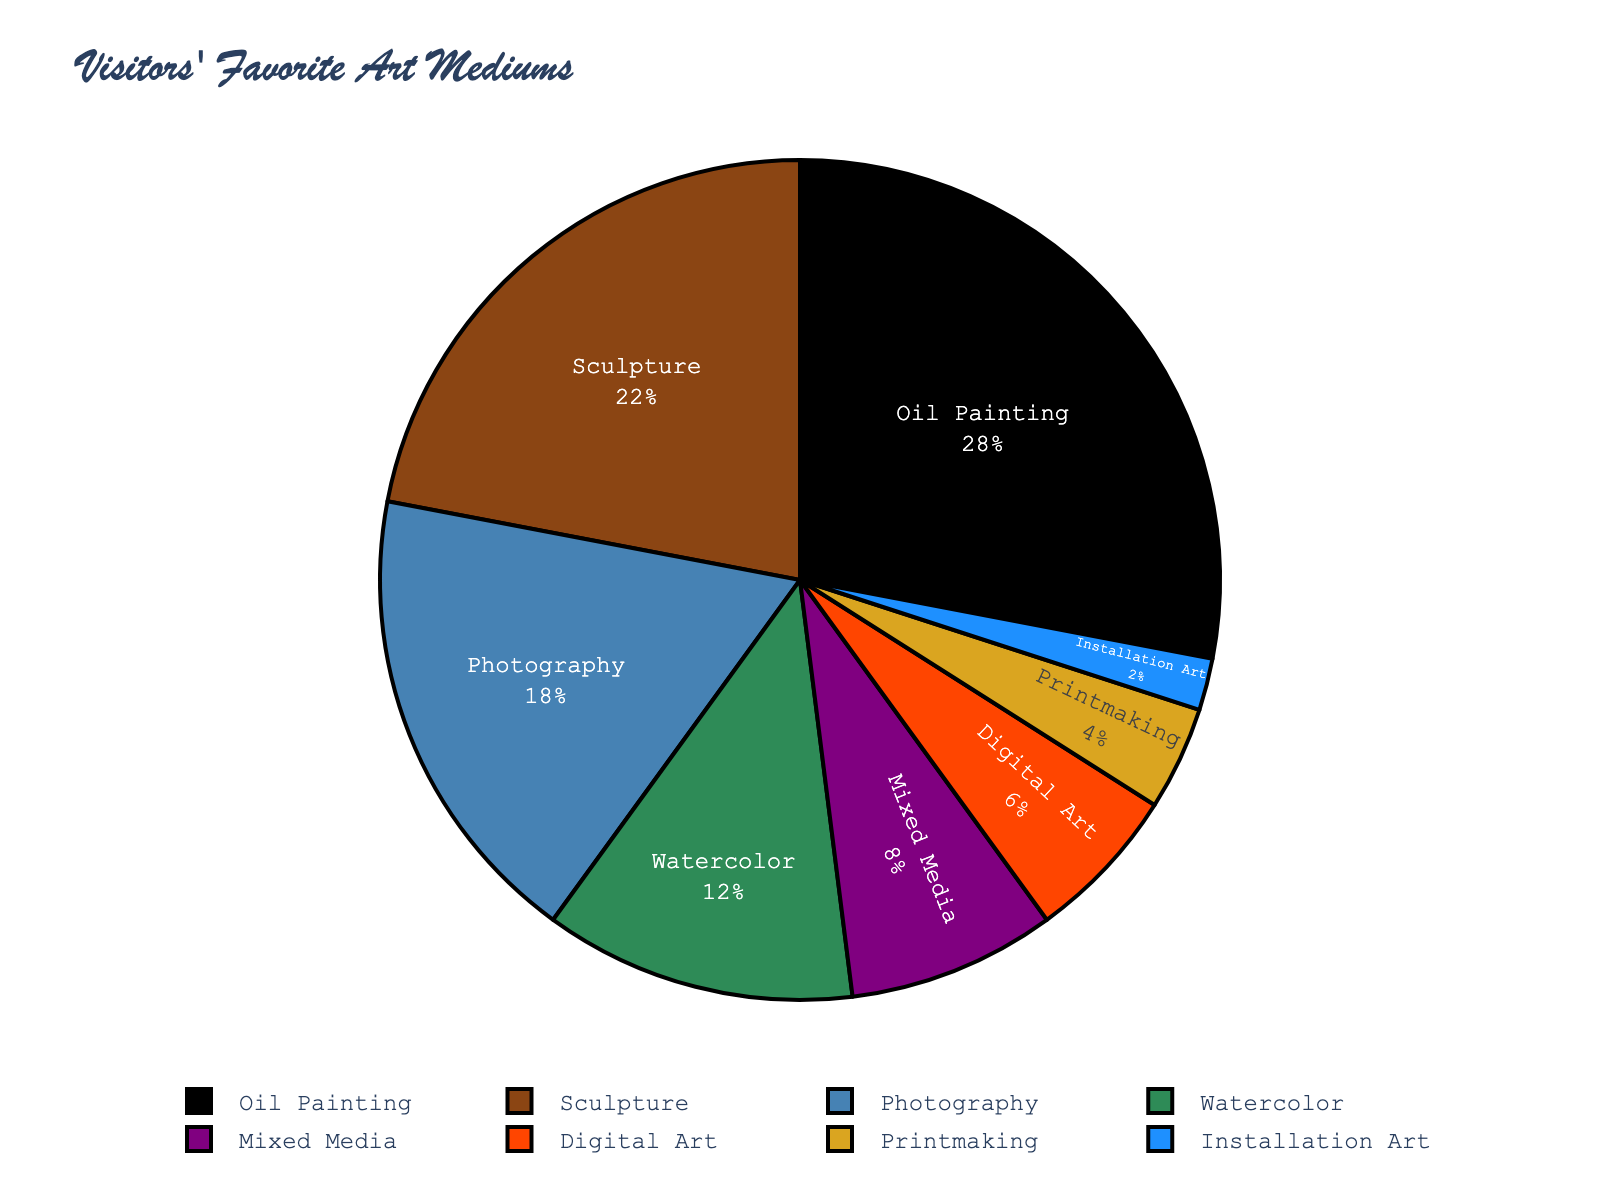what is the combined percentage of visitors who favor Oil Painting and Sculpture? The percentage of visitors who favor Oil Painting is 28% and those who favor Sculpture is 22%. Adding these together gives 28% + 22% = 50%.
Answer: 50% What is the difference in percentage between Photography and Digital Art? The percentage of visitors who favor Photography is 18% and those who favor Digital Art is 6%. The difference is 18% - 6% = 12%.
Answer: 12% What is the least preferred art medium among visitors, and what percentage of visitors prefer it? The least preferred art medium, according to the chart, is Installation Art with a percentage of 2%.
Answer: Installation Art, 2% Which art medium has a percentage closest to but less than 10%? Mixed Media has a percentage closest to but less than 10% with 8%.
Answer: Mixed Media Are there more visitors who favor Watercolor or Printmaking, and by how much? The percentage of visitors who favor Watercolor is 12% and for Printmaking is 4%. Watercolor is favored by 12% - 4% = 8% more visitors.
Answer: Watercolor, 8% What is the total percentage of visitors who prefer either Mixed Media or Digital Art? The percentage of visitors who prefer Mixed Media is 8% and for Digital Art is 6%. The total percentage is 8% + 6% = 14%.
Answer: 14% How does the preference percentage of Sculpture compare to Watercolor? Sculpture has a preference percentage of 22%, while Watercolor has 12%. Sculpture is 22% - 12% = 10% more preferred.
Answer: 10% more Which art medium category has a preference percentage greater than Printmaking but less than Photography? Mixed Media, with a preference percentage of 8%, is greater than Printmaking at 4% but less than Photography at 18%.
Answer: Mixed Media 